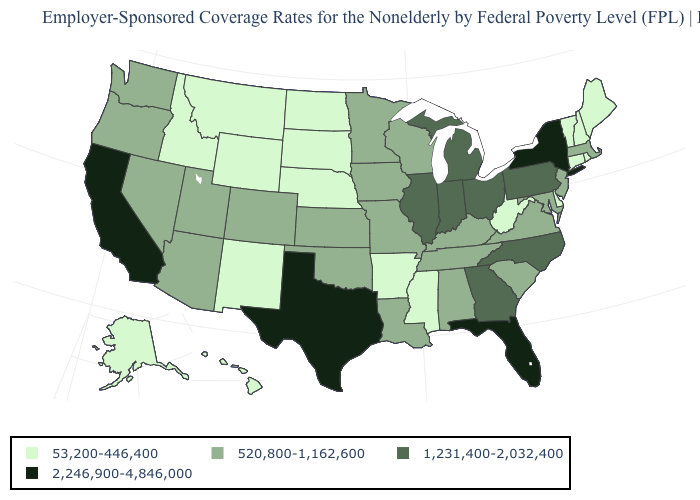What is the value of North Carolina?
Give a very brief answer. 1,231,400-2,032,400. Does the map have missing data?
Quick response, please. No. Name the states that have a value in the range 53,200-446,400?
Short answer required. Alaska, Arkansas, Connecticut, Delaware, Hawaii, Idaho, Maine, Mississippi, Montana, Nebraska, New Hampshire, New Mexico, North Dakota, Rhode Island, South Dakota, Vermont, West Virginia, Wyoming. What is the value of Iowa?
Concise answer only. 520,800-1,162,600. Which states hav the highest value in the Northeast?
Be succinct. New York. What is the value of Hawaii?
Give a very brief answer. 53,200-446,400. What is the value of Louisiana?
Answer briefly. 520,800-1,162,600. What is the highest value in the USA?
Short answer required. 2,246,900-4,846,000. What is the value of Oregon?
Write a very short answer. 520,800-1,162,600. What is the value of Indiana?
Answer briefly. 1,231,400-2,032,400. What is the value of Michigan?
Be succinct. 1,231,400-2,032,400. Does Kansas have the same value as Louisiana?
Short answer required. Yes. What is the highest value in the USA?
Be succinct. 2,246,900-4,846,000. What is the highest value in the USA?
Keep it brief. 2,246,900-4,846,000. 